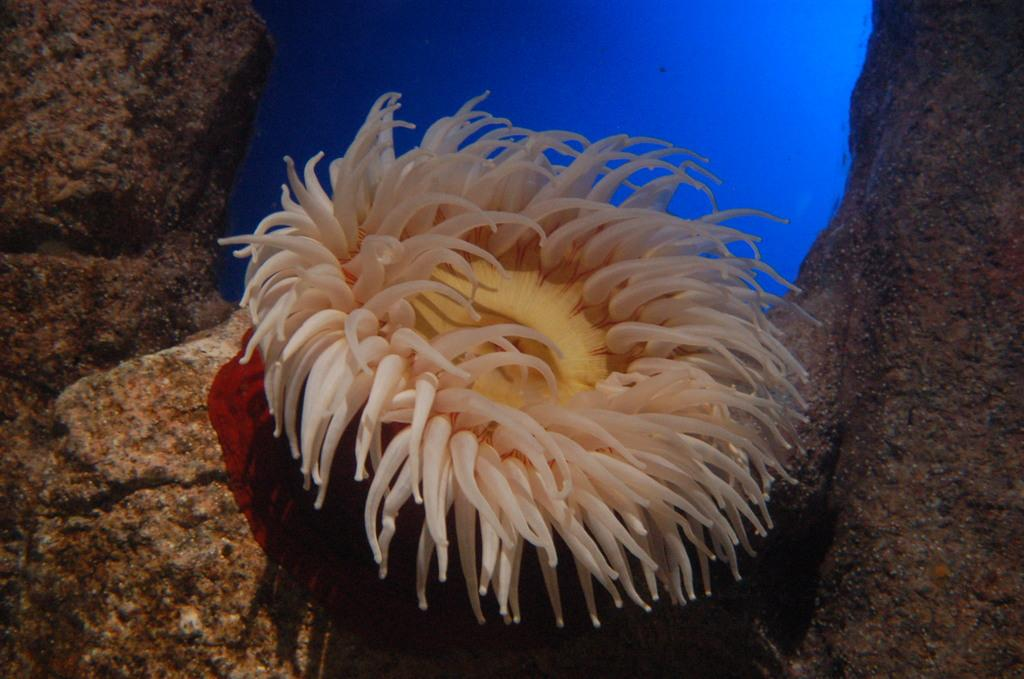What type of animal can be seen in the image? There is an aquatic animal in the image. Where is the animal located? The animal is in the water. What can be seen in the background behind the animal? There are rocks visible behind the animal. How many bikes are parked next to the aquatic animal in the image? There are no bikes present in the image; it features an aquatic animal in the water with rocks visible in the background. 